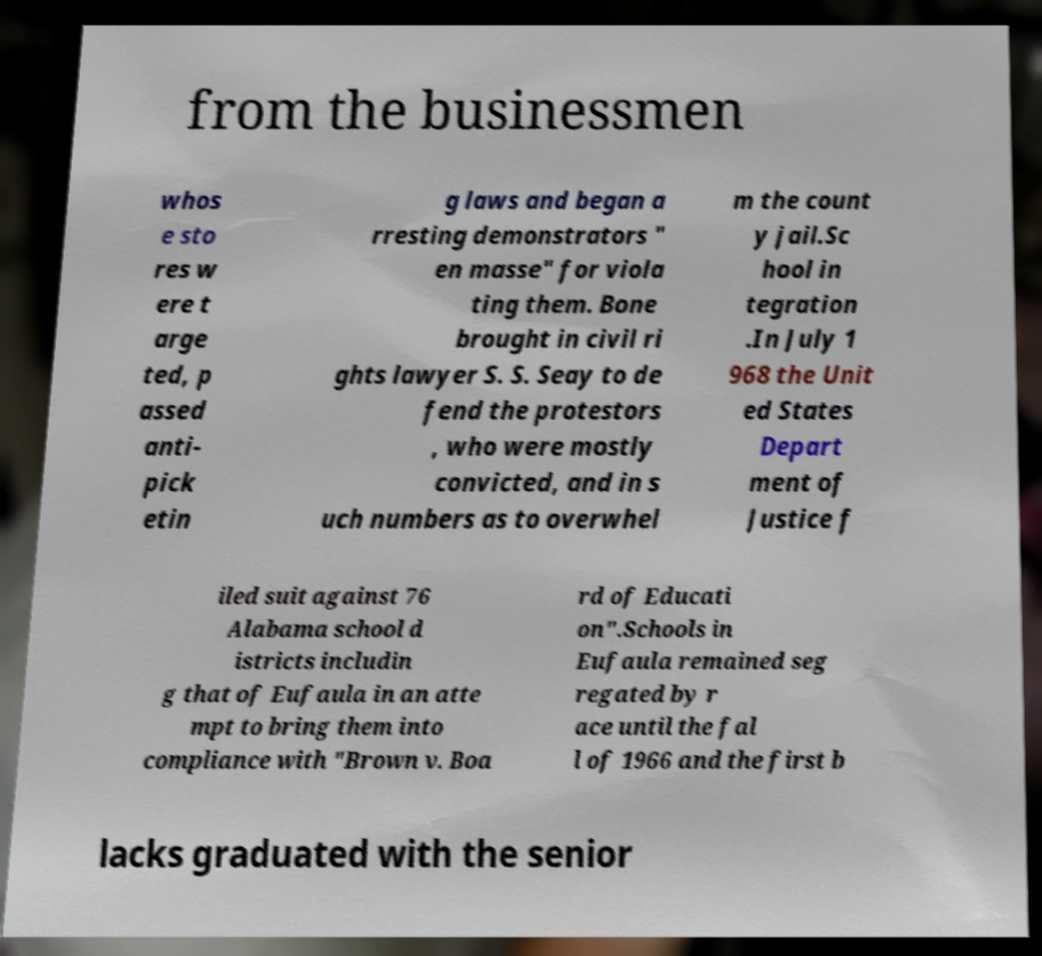Can you accurately transcribe the text from the provided image for me? from the businessmen whos e sto res w ere t arge ted, p assed anti- pick etin g laws and began a rresting demonstrators " en masse" for viola ting them. Bone brought in civil ri ghts lawyer S. S. Seay to de fend the protestors , who were mostly convicted, and in s uch numbers as to overwhel m the count y jail.Sc hool in tegration .In July 1 968 the Unit ed States Depart ment of Justice f iled suit against 76 Alabama school d istricts includin g that of Eufaula in an atte mpt to bring them into compliance with "Brown v. Boa rd of Educati on".Schools in Eufaula remained seg regated by r ace until the fal l of 1966 and the first b lacks graduated with the senior 